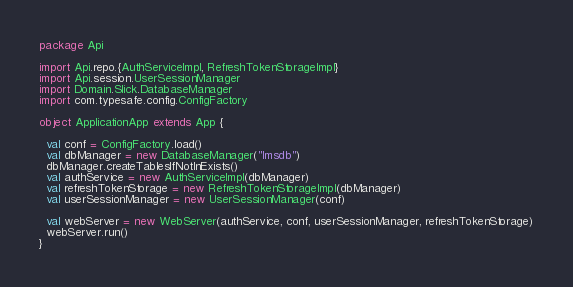Convert code to text. <code><loc_0><loc_0><loc_500><loc_500><_Scala_>package Api

import Api.repo.{AuthServiceImpl, RefreshTokenStorageImpl}
import Api.session.UserSessionManager
import Domain.Slick.DatabaseManager
import com.typesafe.config.ConfigFactory

object ApplicationApp extends App {

  val conf = ConfigFactory.load()
  val dbManager = new DatabaseManager("lmsdb")
  dbManager.createTablesIfNotInExists()
  val authService = new AuthServiceImpl(dbManager)
  val refreshTokenStorage = new RefreshTokenStorageImpl(dbManager)
  val userSessionManager = new UserSessionManager(conf)

  val webServer = new WebServer(authService, conf, userSessionManager, refreshTokenStorage)
  webServer.run()
}
</code> 